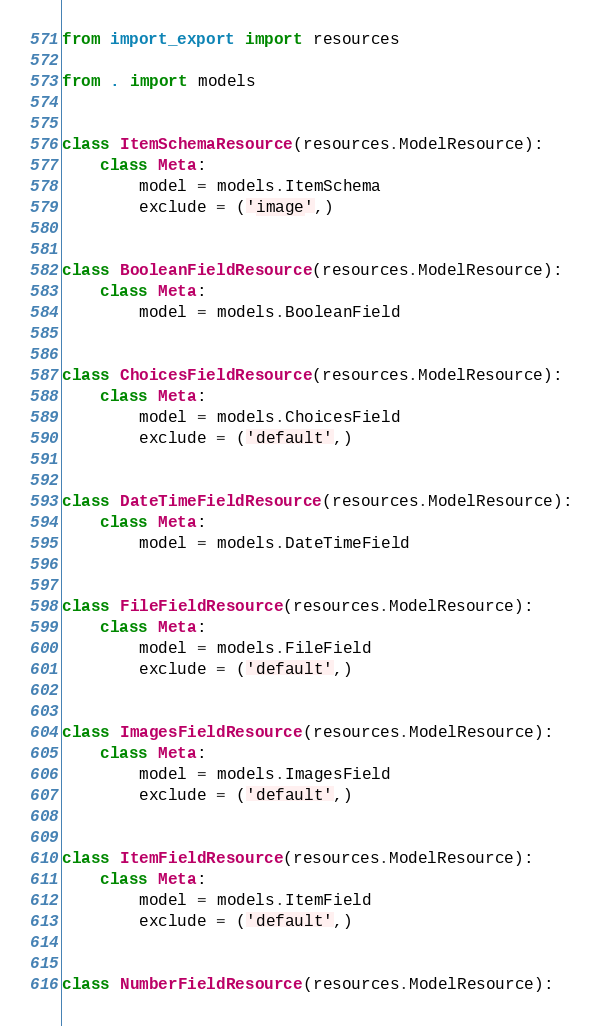Convert code to text. <code><loc_0><loc_0><loc_500><loc_500><_Python_>from import_export import resources

from . import models


class ItemSchemaResource(resources.ModelResource):
    class Meta:
        model = models.ItemSchema
        exclude = ('image',)


class BooleanFieldResource(resources.ModelResource):
    class Meta:
        model = models.BooleanField


class ChoicesFieldResource(resources.ModelResource):
    class Meta:
        model = models.ChoicesField
        exclude = ('default',)


class DateTimeFieldResource(resources.ModelResource):
    class Meta:
        model = models.DateTimeField


class FileFieldResource(resources.ModelResource):
    class Meta:
        model = models.FileField
        exclude = ('default',)


class ImagesFieldResource(resources.ModelResource):
    class Meta:
        model = models.ImagesField
        exclude = ('default',)


class ItemFieldResource(resources.ModelResource):
    class Meta:
        model = models.ItemField
        exclude = ('default',)


class NumberFieldResource(resources.ModelResource):</code> 